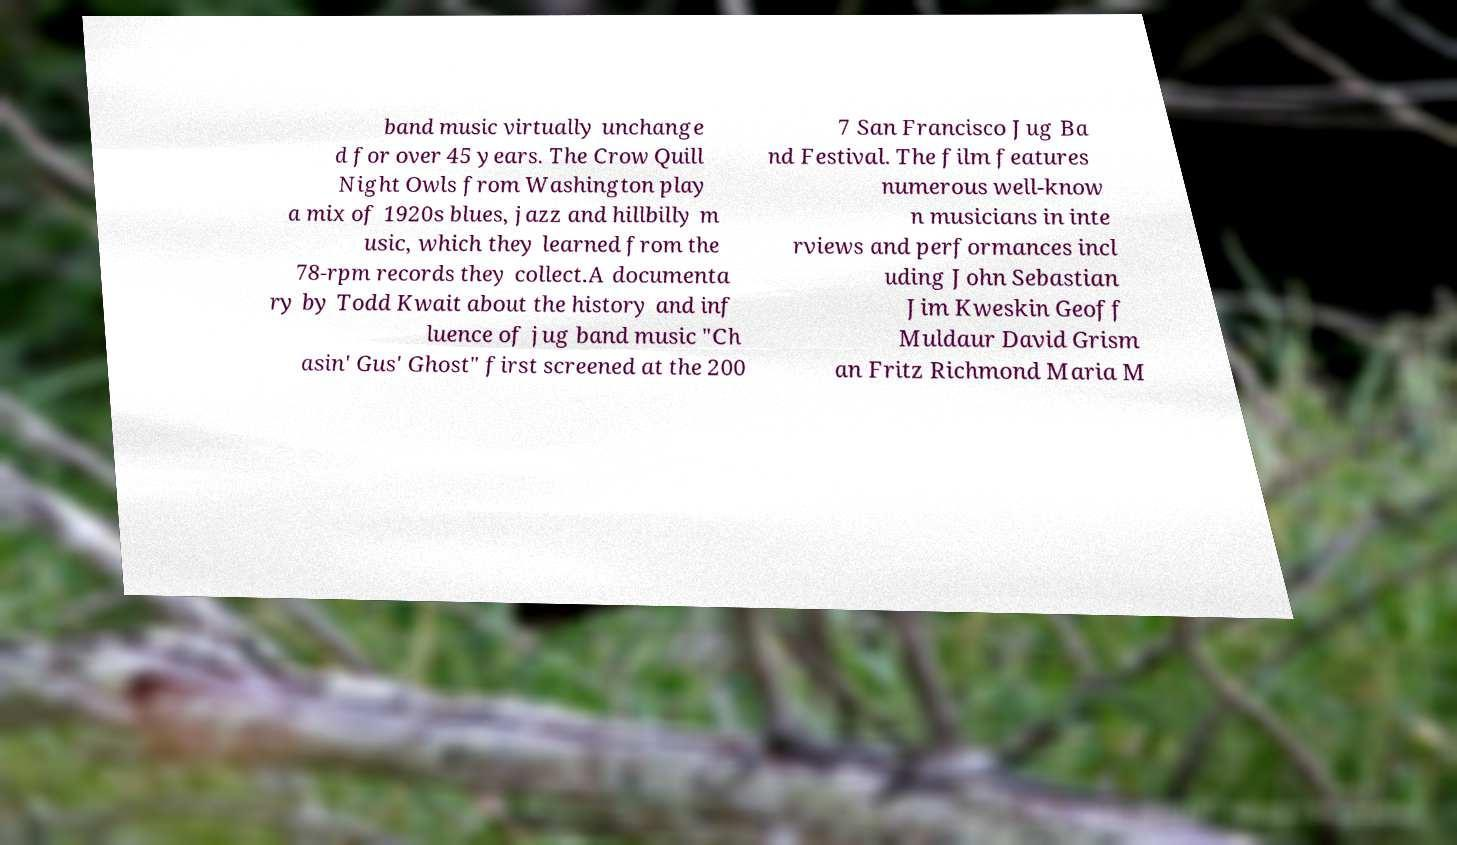I need the written content from this picture converted into text. Can you do that? band music virtually unchange d for over 45 years. The Crow Quill Night Owls from Washington play a mix of 1920s blues, jazz and hillbilly m usic, which they learned from the 78-rpm records they collect.A documenta ry by Todd Kwait about the history and inf luence of jug band music "Ch asin' Gus' Ghost" first screened at the 200 7 San Francisco Jug Ba nd Festival. The film features numerous well-know n musicians in inte rviews and performances incl uding John Sebastian Jim Kweskin Geoff Muldaur David Grism an Fritz Richmond Maria M 